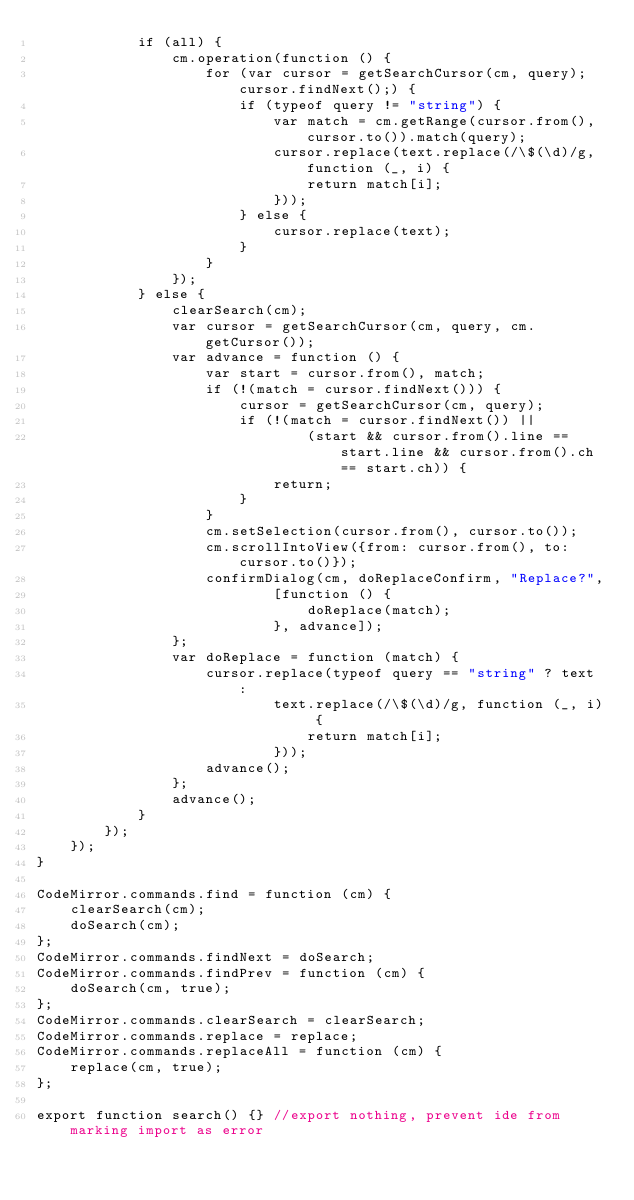<code> <loc_0><loc_0><loc_500><loc_500><_JavaScript_>            if (all) {
                cm.operation(function () {
                    for (var cursor = getSearchCursor(cm, query); cursor.findNext();) {
                        if (typeof query != "string") {
                            var match = cm.getRange(cursor.from(), cursor.to()).match(query);
                            cursor.replace(text.replace(/\$(\d)/g, function (_, i) {
                                return match[i];
                            }));
                        } else {
                            cursor.replace(text);
                        }
                    }
                });
            } else {
                clearSearch(cm);
                var cursor = getSearchCursor(cm, query, cm.getCursor());
                var advance = function () {
                    var start = cursor.from(), match;
                    if (!(match = cursor.findNext())) {
                        cursor = getSearchCursor(cm, query);
                        if (!(match = cursor.findNext()) ||
                                (start && cursor.from().line == start.line && cursor.from().ch == start.ch)) {
                            return;
                        }
                    }
                    cm.setSelection(cursor.from(), cursor.to());
                    cm.scrollIntoView({from: cursor.from(), to: cursor.to()});
                    confirmDialog(cm, doReplaceConfirm, "Replace?",
                            [function () {
                                doReplace(match);
                            }, advance]);
                };
                var doReplace = function (match) {
                    cursor.replace(typeof query == "string" ? text :
                            text.replace(/\$(\d)/g, function (_, i) {
                                return match[i];
                            }));
                    advance();
                };
                advance();
            }
        });
    });
}

CodeMirror.commands.find = function (cm) {
    clearSearch(cm);
    doSearch(cm);
};
CodeMirror.commands.findNext = doSearch;
CodeMirror.commands.findPrev = function (cm) {
    doSearch(cm, true);
};
CodeMirror.commands.clearSearch = clearSearch;
CodeMirror.commands.replace = replace;
CodeMirror.commands.replaceAll = function (cm) {
    replace(cm, true);
};

export function search() {} //export nothing, prevent ide from marking import as error</code> 